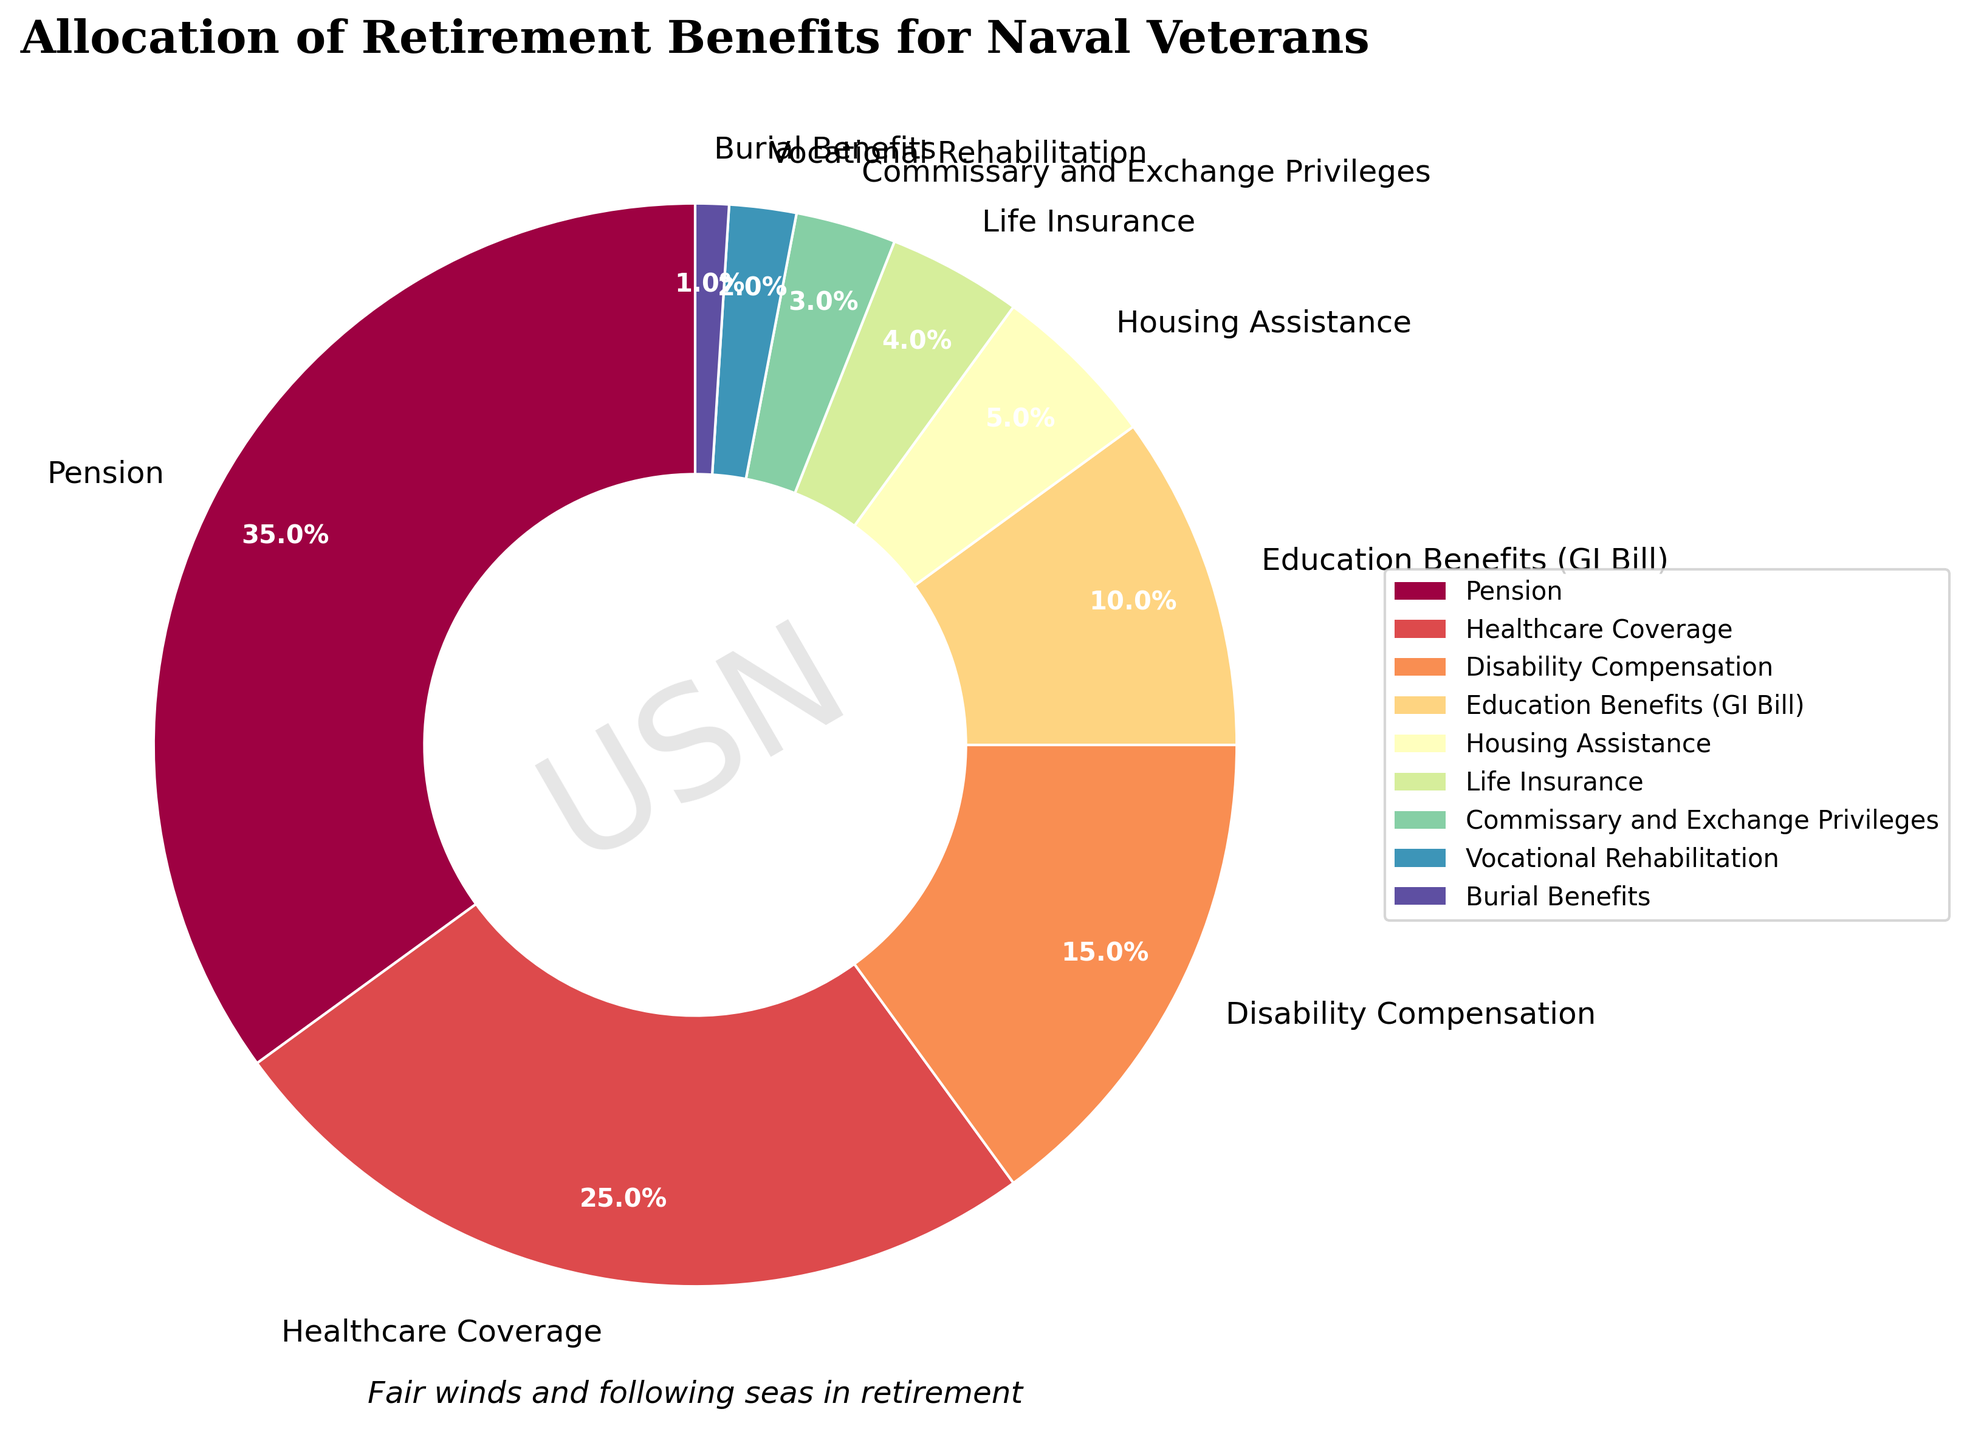Which category has the highest percentage? From the pie chart, 'Pension' has the largest segment, indicating it has the highest allocation percentage.
Answer: Pension Which category has a smaller percentage: Life Insurance or Housing Assistance? By comparing the size of the pie chart segments, 'Life Insurance' has a smaller percentage than 'Housing Assistance'.
Answer: Life Insurance What is the combined percentage of Education Benefits (GI Bill) and Housing Assistance? Education Benefits (GI Bill) is 10% and Housing Assistance is 5%. Adding them together gives 10 + 5 = 15%.
Answer: 15% Is the percentage allocated to Disability Compensation higher or lower than Healthcare Coverage? By inspecting the pie chart, Disability Compensation is 15%, which is lower than Healthcare Coverage at 25%.
Answer: Lower What is the total percentage allocated to benefits other than Pension? Subtracting the percentage of 'Pension' (35%) from 100% gives the combined total for all other categories, which is 100 - 35 = 65%.
Answer: 65% Which category has the third highest allocation? The third largest segment in the pie chart, after Pension and Healthcare Coverage, is Disability Compensation at 15%.
Answer: Disability Compensation How does the size of the Life Insurance segment compare to the Vocational Rehabilitation segment? By checking the segments in the pie chart, 'Life Insurance' is 4% and larger than 'Vocational Rehabilitation' at 2%.
Answer: Life Insurance is larger What is the total percentage allocated to Healthcare Coverage and Disability Compensation combined? Adding the percentages of 'Healthcare Coverage' (25%) and 'Disability Compensation' (15%) gives a total of 25 + 15 = 40%.
Answer: 40% If we group Housing Assistance, Life Insurance, Commissary and Exchange Privileges, Vocational Rehabilitation, and Burial Benefits together, what's their combined percentage? Adding the percentages for these categories: Housing Assistance (5%) + Life Insurance (4%) + Commissary and Exchange Privileges (3%) + Vocational Rehabilitation (2%) + Burial Benefits (1%) gives a total of 5 + 4 + 3 + 2 + 1 = 15%.
Answer: 15% Which two categories together constitute exactly 40% of the total benefits? The sum of 'Healthcare Coverage' (25%) and 'Education Benefits (GI Bill)' (10%) combined with 'Burial Benefits' (1%) exactly equals 25 + 10 + 1 = 40%.
Answer: Healthcare Coverage and Education Benefits (GI Bill) 